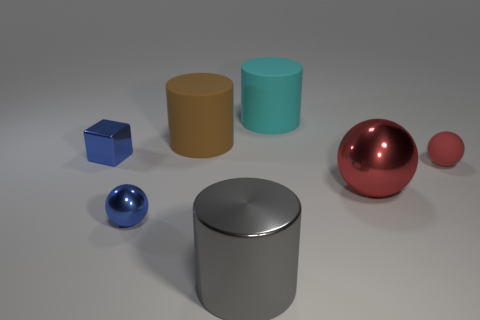Does the small rubber object have the same color as the metal ball that is on the right side of the brown rubber cylinder?
Offer a terse response. Yes. There is a small sphere that is in front of the red object on the right side of the large metal thing that is behind the big gray thing; what color is it?
Keep it short and to the point. Blue. What is the color of the large object that is the same shape as the small red rubber object?
Your answer should be compact. Red. Are there the same number of tiny metal spheres in front of the shiny cylinder and tiny matte objects?
Provide a short and direct response. No. How many cubes are either cyan things or gray objects?
Provide a short and direct response. 0. What is the color of the cylinder that is the same material as the big red sphere?
Make the answer very short. Gray. Does the large gray object have the same material as the tiny ball that is on the right side of the cyan matte thing?
Your answer should be compact. No. What number of objects are small gray objects or blocks?
Your response must be concise. 1. What material is the tiny block that is the same color as the small metallic sphere?
Provide a succinct answer. Metal. Are there any big gray objects that have the same shape as the large cyan thing?
Make the answer very short. Yes. 